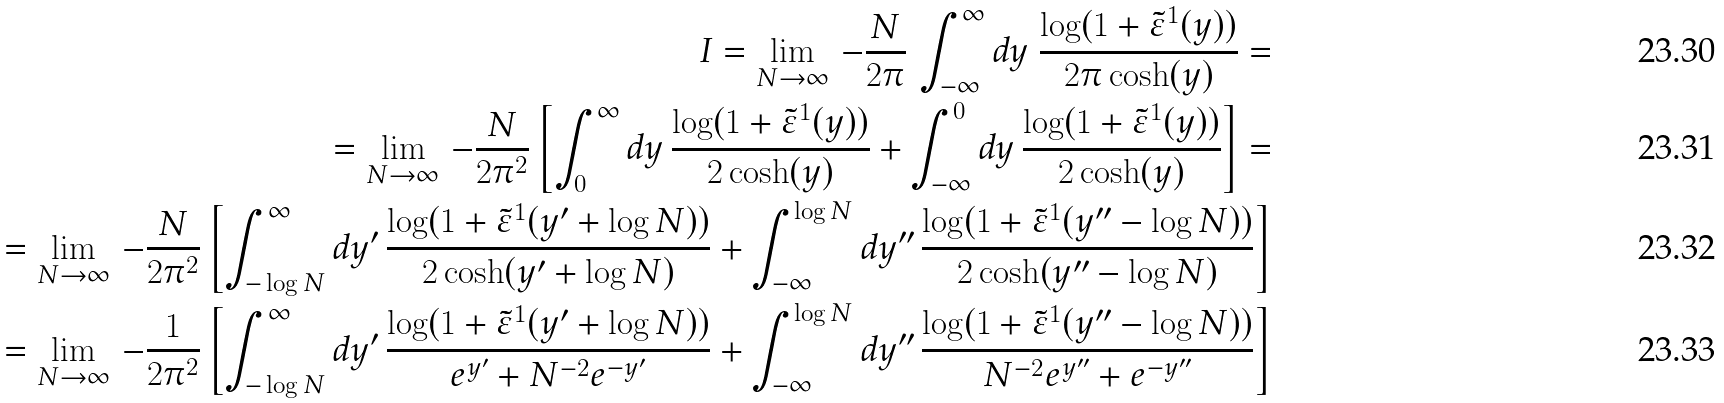Convert formula to latex. <formula><loc_0><loc_0><loc_500><loc_500>I = \lim _ { N \rightarrow \infty } \, - \frac { N } { 2 \pi } \, \int _ { - \infty } ^ { \infty } d y \ \frac { \log ( 1 + { \tilde { \varepsilon } } ^ { 1 } ( y ) ) } { 2 \pi \cosh ( y ) } = \\ = \lim _ { N \rightarrow \infty } \, - \frac { N } { 2 \pi ^ { 2 } } \left [ \int _ { 0 } ^ { \infty } d y \, \frac { \log ( 1 + { \tilde { \varepsilon } } ^ { 1 } ( y ) ) } { 2 \cosh ( y ) } + \int _ { - \infty } ^ { 0 } d y \, \frac { \log ( 1 + { \tilde { \varepsilon } } ^ { 1 } ( y ) ) } { 2 \cosh ( y ) } \right ] = \\ = \lim _ { N \rightarrow \infty } \, - \frac { N } { 2 \pi ^ { 2 } } \left [ \int _ { - \log N } ^ { \infty } d y ^ { \prime } \, \frac { \log ( 1 + { \tilde { \varepsilon } } ^ { 1 } ( y ^ { \prime } + \log N ) ) } { 2 \cosh ( y ^ { \prime } + \log N ) } + \int _ { - \infty } ^ { \log N } d y ^ { \prime \prime } \, \frac { \log ( 1 + { \tilde { \varepsilon } } ^ { 1 } ( y ^ { \prime \prime } - \log N ) ) } { 2 \cosh ( y ^ { \prime \prime } - \log N ) } \right ] \\ = \lim _ { N \rightarrow \infty } \, - \frac { 1 } { 2 \pi ^ { 2 } } \left [ \int _ { - \log N } ^ { \infty } d y ^ { \prime } \, \frac { \log ( 1 + { \tilde { \varepsilon } } ^ { 1 } ( y ^ { \prime } + \log N ) ) } { e ^ { y ^ { \prime } } + N ^ { - 2 } e ^ { - y ^ { \prime } } } + \int _ { - \infty } ^ { \log N } d y ^ { \prime \prime } \, \frac { \log ( 1 + { \tilde { \varepsilon } } ^ { 1 } ( y ^ { \prime \prime } - \log N ) ) } { N ^ { - 2 } e ^ { y ^ { \prime \prime } } + e ^ { - y ^ { \prime \prime } } } \right ]</formula> 